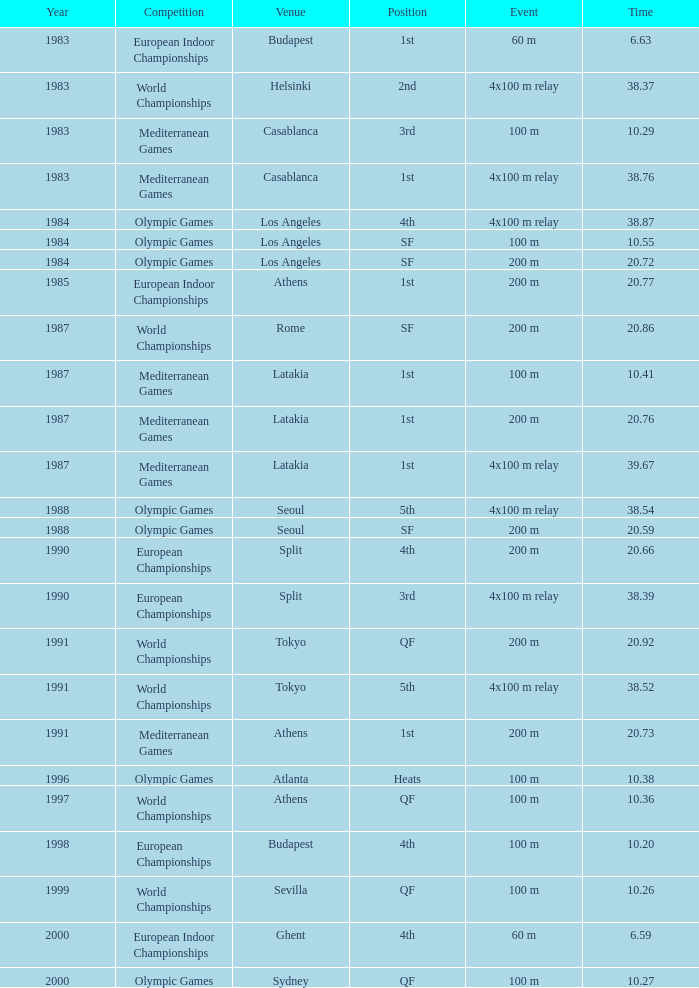What incident has a standing of 1st, an annual of 1983, and a place of budapest? 60 m. 